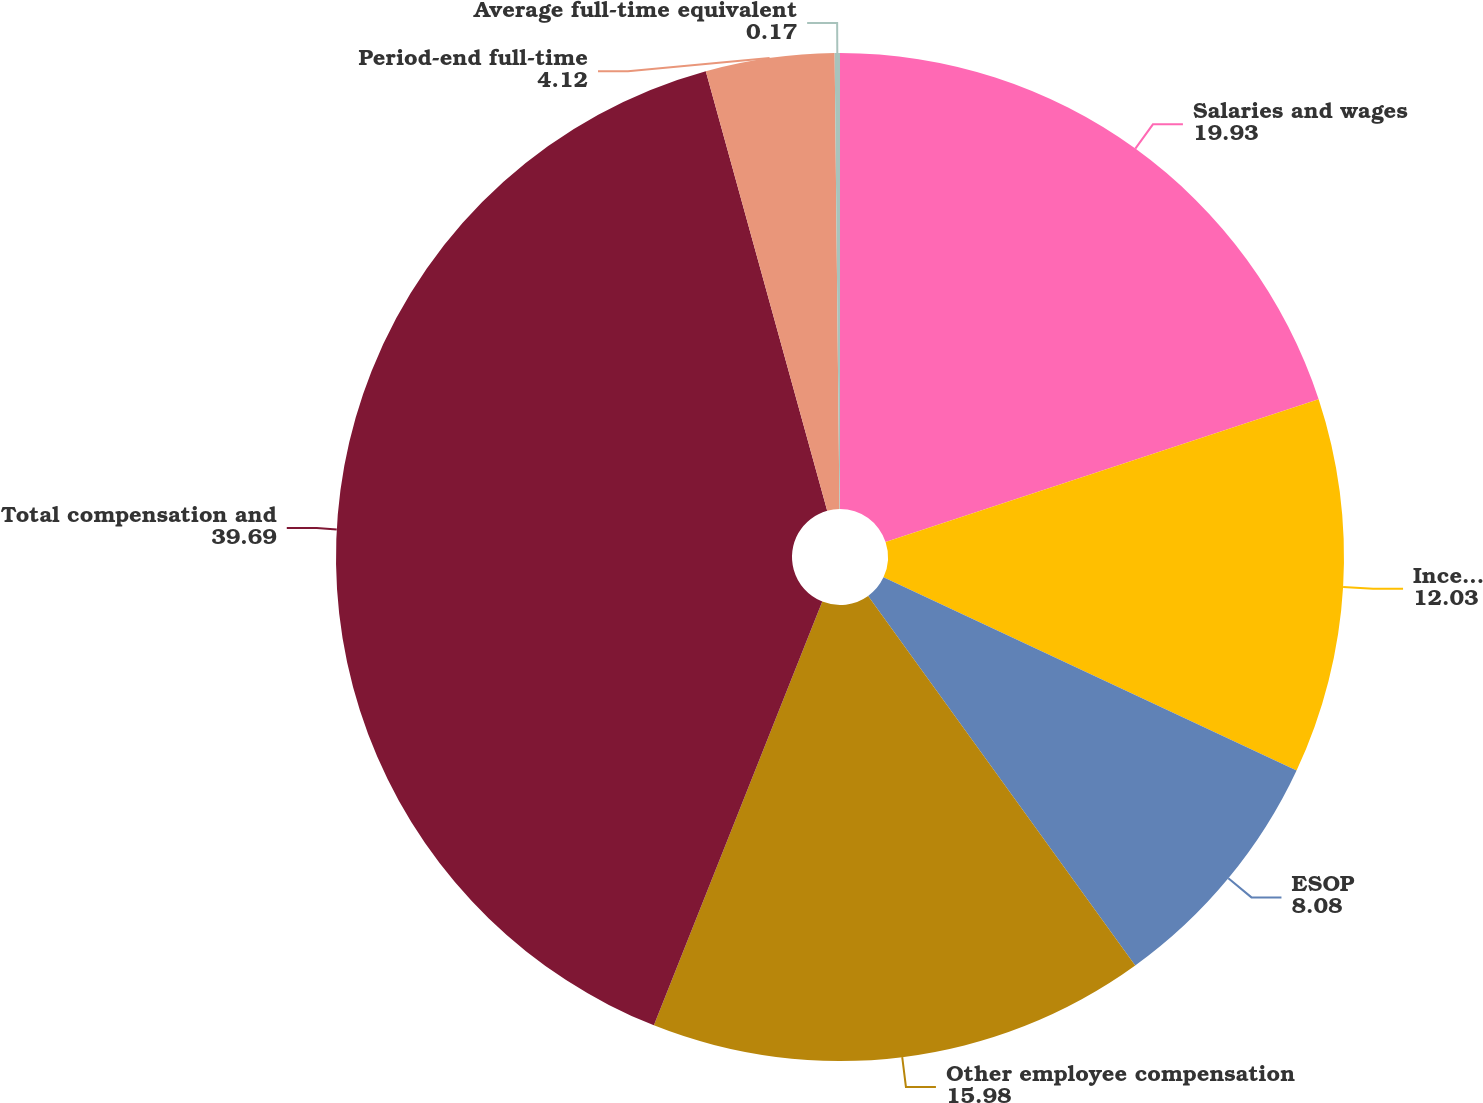Convert chart to OTSL. <chart><loc_0><loc_0><loc_500><loc_500><pie_chart><fcel>Salaries and wages<fcel>Incentive compensation<fcel>ESOP<fcel>Other employee compensation<fcel>Total compensation and<fcel>Period-end full-time<fcel>Average full-time equivalent<nl><fcel>19.93%<fcel>12.03%<fcel>8.08%<fcel>15.98%<fcel>39.69%<fcel>4.12%<fcel>0.17%<nl></chart> 